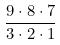<formula> <loc_0><loc_0><loc_500><loc_500>\frac { 9 \cdot 8 \cdot 7 } { 3 \cdot 2 \cdot 1 }</formula> 